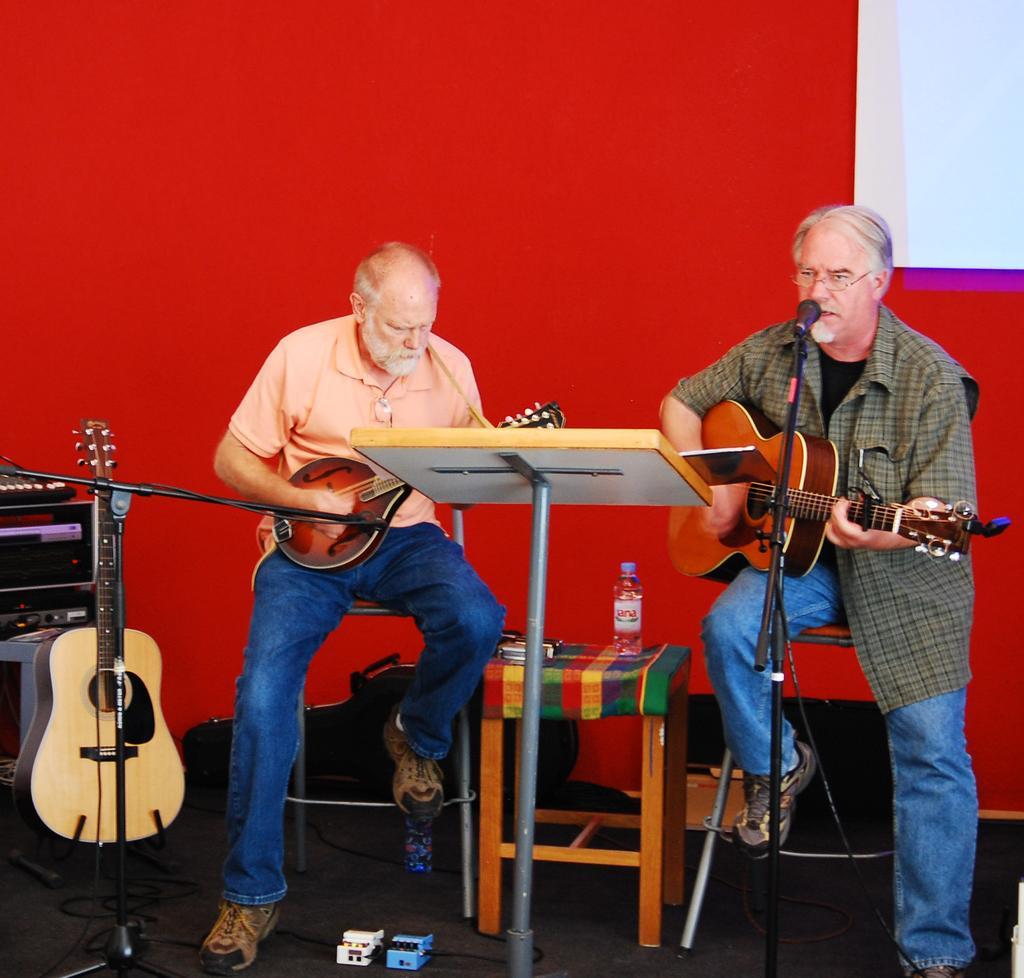In one or two sentences, can you explain what this image depicts? The image is inside the room. In the image there is a man siting on chair and playing guitar infront of a microphone, on left side there is a another man playing his musical instrument. In background we can see a guitar,speakers,table,water bottle and red color wall and a white color screen. 